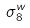Convert formula to latex. <formula><loc_0><loc_0><loc_500><loc_500>\sigma _ { 8 } ^ { w }</formula> 